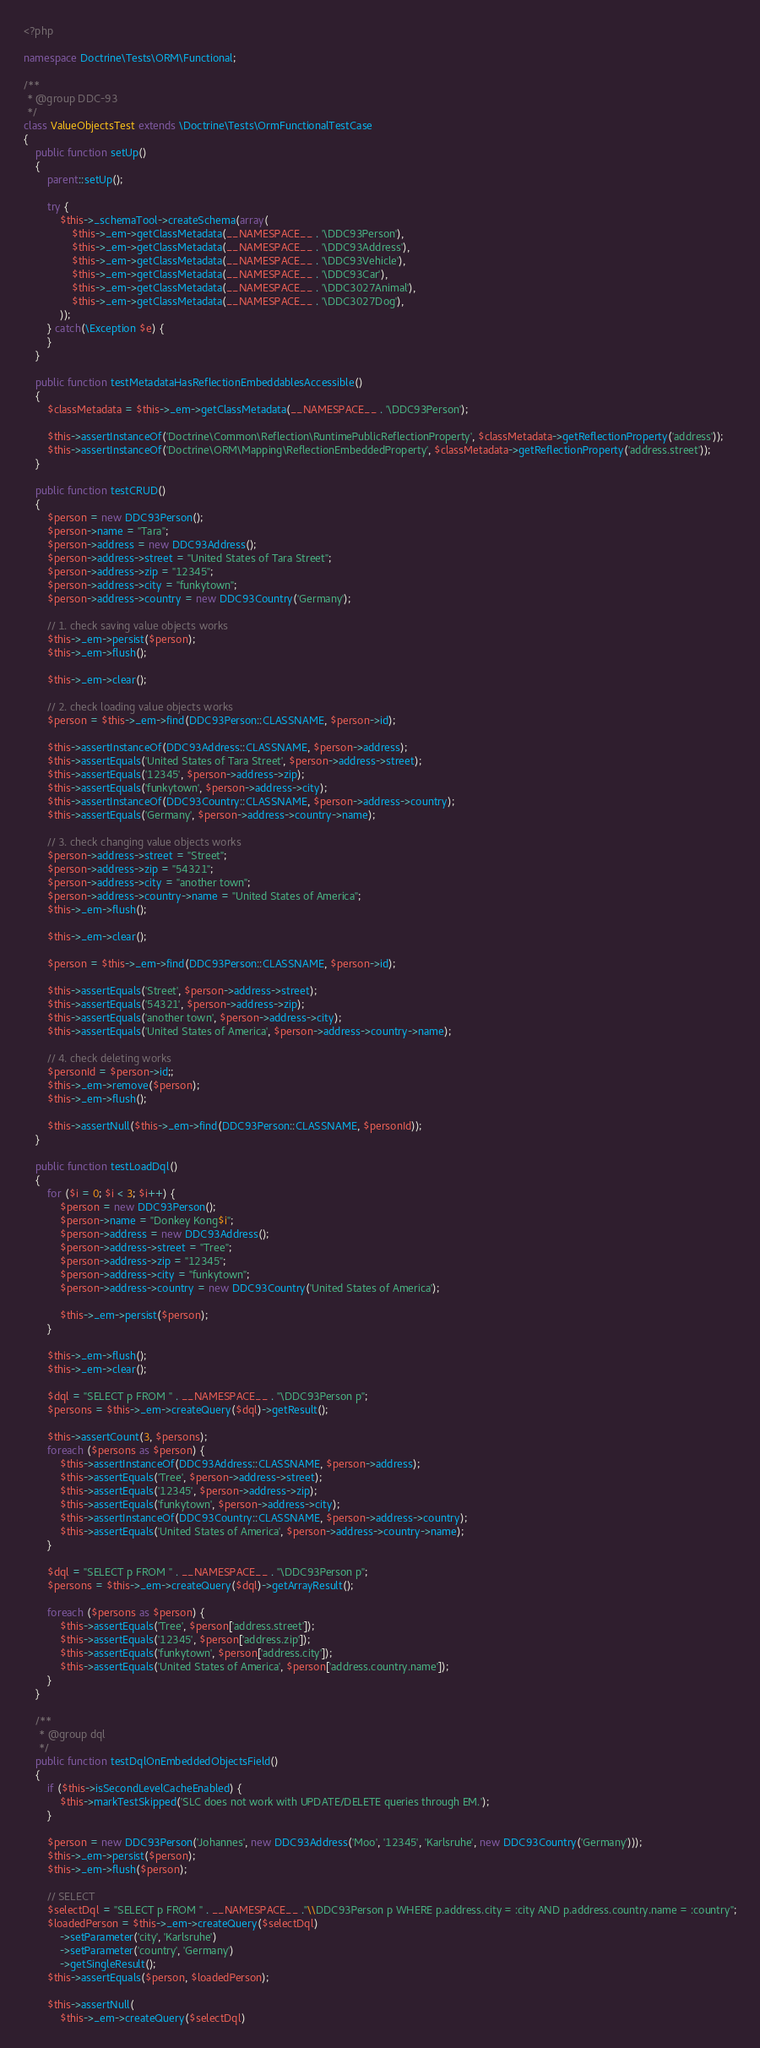<code> <loc_0><loc_0><loc_500><loc_500><_PHP_><?php

namespace Doctrine\Tests\ORM\Functional;

/**
 * @group DDC-93
 */
class ValueObjectsTest extends \Doctrine\Tests\OrmFunctionalTestCase
{
    public function setUp()
    {
        parent::setUp();

        try {
            $this->_schemaTool->createSchema(array(
                $this->_em->getClassMetadata(__NAMESPACE__ . '\DDC93Person'),
                $this->_em->getClassMetadata(__NAMESPACE__ . '\DDC93Address'),
                $this->_em->getClassMetadata(__NAMESPACE__ . '\DDC93Vehicle'),
                $this->_em->getClassMetadata(__NAMESPACE__ . '\DDC93Car'),
                $this->_em->getClassMetadata(__NAMESPACE__ . '\DDC3027Animal'),
                $this->_em->getClassMetadata(__NAMESPACE__ . '\DDC3027Dog'),
            ));
        } catch(\Exception $e) {
        }
    }

    public function testMetadataHasReflectionEmbeddablesAccessible()
    {
        $classMetadata = $this->_em->getClassMetadata(__NAMESPACE__ . '\DDC93Person');

        $this->assertInstanceOf('Doctrine\Common\Reflection\RuntimePublicReflectionProperty', $classMetadata->getReflectionProperty('address'));
        $this->assertInstanceOf('Doctrine\ORM\Mapping\ReflectionEmbeddedProperty', $classMetadata->getReflectionProperty('address.street'));
    }

    public function testCRUD()
    {
        $person = new DDC93Person();
        $person->name = "Tara";
        $person->address = new DDC93Address();
        $person->address->street = "United States of Tara Street";
        $person->address->zip = "12345";
        $person->address->city = "funkytown";
        $person->address->country = new DDC93Country('Germany');

        // 1. check saving value objects works
        $this->_em->persist($person);
        $this->_em->flush();

        $this->_em->clear();

        // 2. check loading value objects works
        $person = $this->_em->find(DDC93Person::CLASSNAME, $person->id);

        $this->assertInstanceOf(DDC93Address::CLASSNAME, $person->address);
        $this->assertEquals('United States of Tara Street', $person->address->street);
        $this->assertEquals('12345', $person->address->zip);
        $this->assertEquals('funkytown', $person->address->city);
        $this->assertInstanceOf(DDC93Country::CLASSNAME, $person->address->country);
        $this->assertEquals('Germany', $person->address->country->name);

        // 3. check changing value objects works
        $person->address->street = "Street";
        $person->address->zip = "54321";
        $person->address->city = "another town";
        $person->address->country->name = "United States of America";
        $this->_em->flush();

        $this->_em->clear();

        $person = $this->_em->find(DDC93Person::CLASSNAME, $person->id);

        $this->assertEquals('Street', $person->address->street);
        $this->assertEquals('54321', $person->address->zip);
        $this->assertEquals('another town', $person->address->city);
        $this->assertEquals('United States of America', $person->address->country->name);

        // 4. check deleting works
        $personId = $person->id;;
        $this->_em->remove($person);
        $this->_em->flush();

        $this->assertNull($this->_em->find(DDC93Person::CLASSNAME, $personId));
    }

    public function testLoadDql()
    {
        for ($i = 0; $i < 3; $i++) {
            $person = new DDC93Person();
            $person->name = "Donkey Kong$i";
            $person->address = new DDC93Address();
            $person->address->street = "Tree";
            $person->address->zip = "12345";
            $person->address->city = "funkytown";
            $person->address->country = new DDC93Country('United States of America');

            $this->_em->persist($person);
        }

        $this->_em->flush();
        $this->_em->clear();

        $dql = "SELECT p FROM " . __NAMESPACE__ . "\DDC93Person p";
        $persons = $this->_em->createQuery($dql)->getResult();

        $this->assertCount(3, $persons);
        foreach ($persons as $person) {
            $this->assertInstanceOf(DDC93Address::CLASSNAME, $person->address);
            $this->assertEquals('Tree', $person->address->street);
            $this->assertEquals('12345', $person->address->zip);
            $this->assertEquals('funkytown', $person->address->city);
            $this->assertInstanceOf(DDC93Country::CLASSNAME, $person->address->country);
            $this->assertEquals('United States of America', $person->address->country->name);
        }

        $dql = "SELECT p FROM " . __NAMESPACE__ . "\DDC93Person p";
        $persons = $this->_em->createQuery($dql)->getArrayResult();

        foreach ($persons as $person) {
            $this->assertEquals('Tree', $person['address.street']);
            $this->assertEquals('12345', $person['address.zip']);
            $this->assertEquals('funkytown', $person['address.city']);
            $this->assertEquals('United States of America', $person['address.country.name']);
        }
    }

    /**
     * @group dql
     */
    public function testDqlOnEmbeddedObjectsField()
    {
        if ($this->isSecondLevelCacheEnabled) {
            $this->markTestSkipped('SLC does not work with UPDATE/DELETE queries through EM.');
        }

        $person = new DDC93Person('Johannes', new DDC93Address('Moo', '12345', 'Karlsruhe', new DDC93Country('Germany')));
        $this->_em->persist($person);
        $this->_em->flush($person);

        // SELECT
        $selectDql = "SELECT p FROM " . __NAMESPACE__ ."\\DDC93Person p WHERE p.address.city = :city AND p.address.country.name = :country";
        $loadedPerson = $this->_em->createQuery($selectDql)
            ->setParameter('city', 'Karlsruhe')
            ->setParameter('country', 'Germany')
            ->getSingleResult();
        $this->assertEquals($person, $loadedPerson);

        $this->assertNull(
            $this->_em->createQuery($selectDql)</code> 